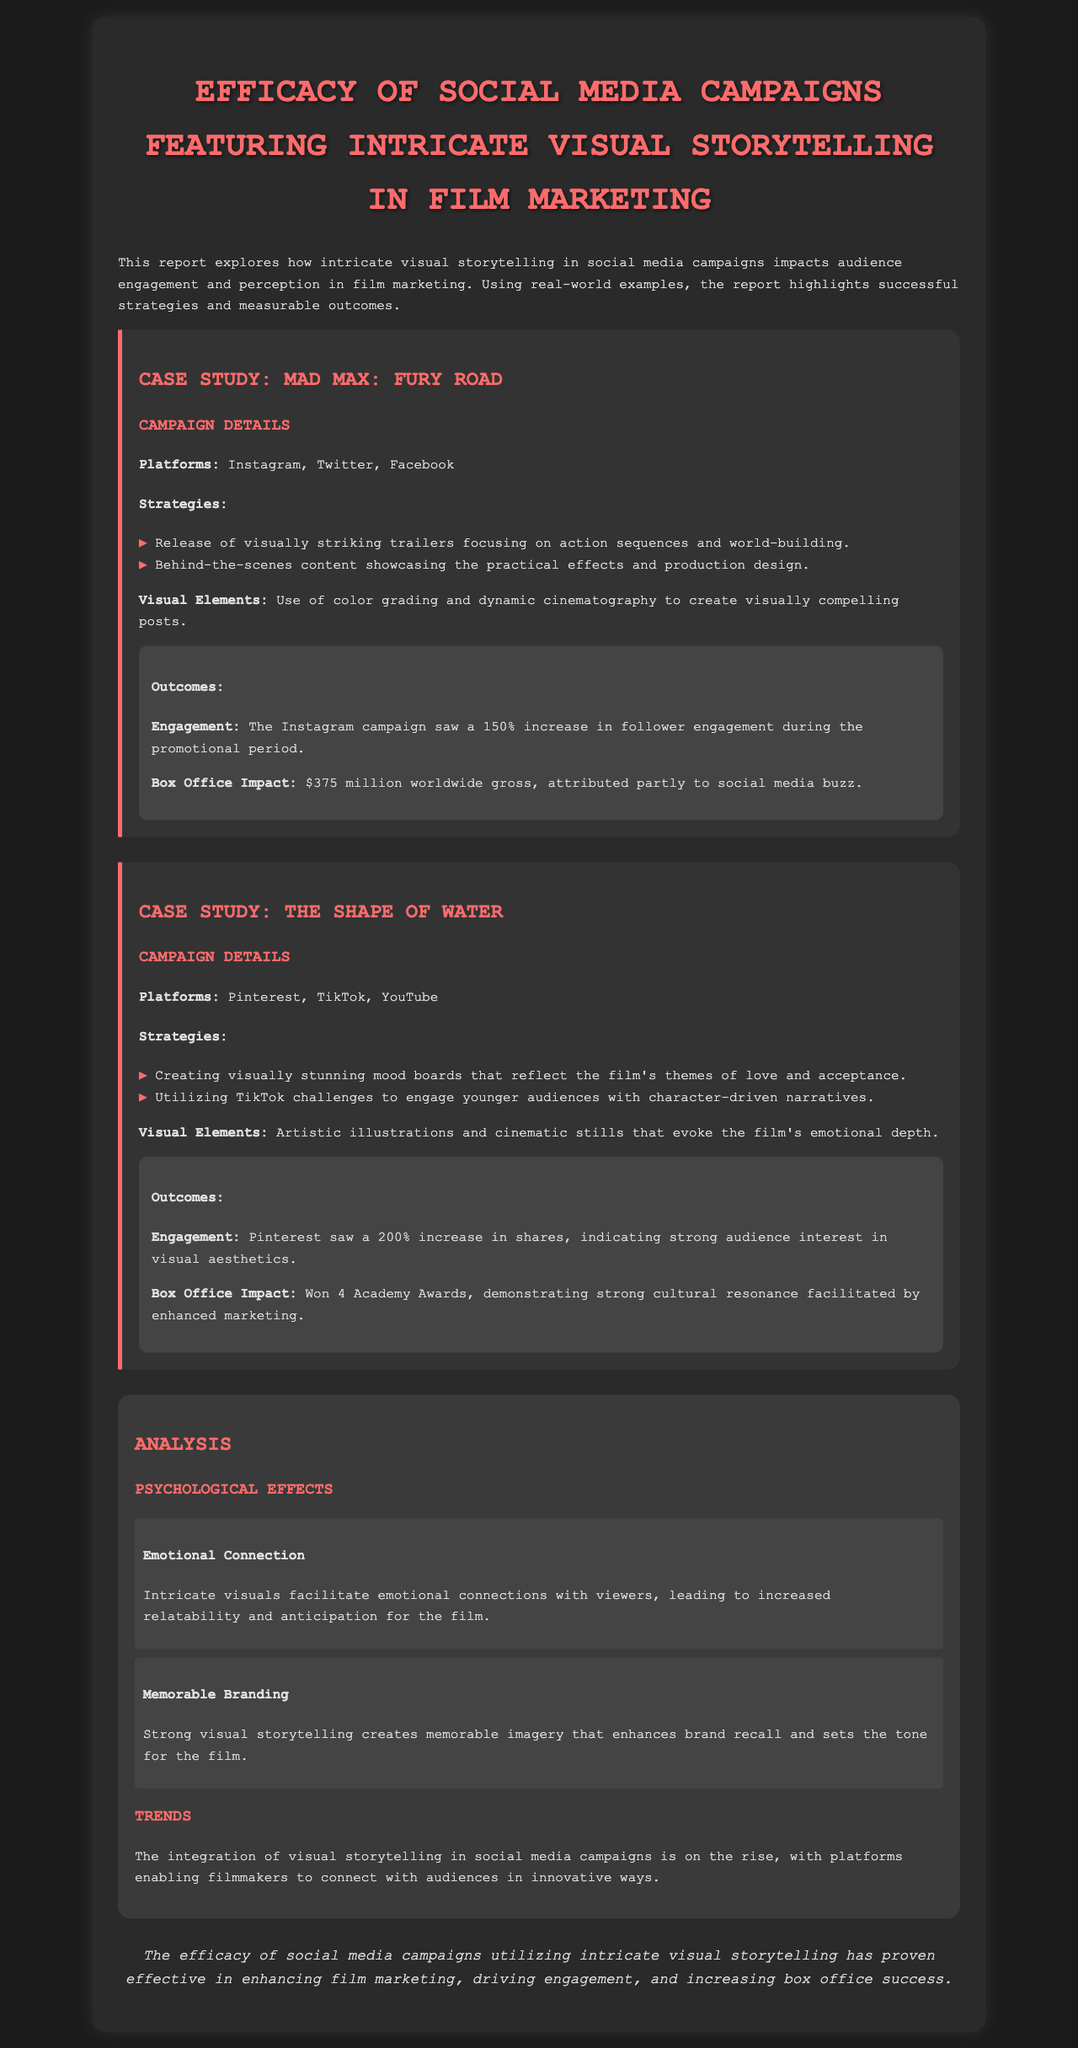what was the engagement increase percentage for Mad Max: Fury Road on Instagram? The engagement increase percentage for the Mad Max: Fury Road Instagram campaign is stated as a 150% increase during the promotional period.
Answer: 150% which platforms were used for The Shape of Water's campaign? The report lists the platforms used for The Shape of Water's campaign as Pinterest, TikTok, and YouTube.
Answer: Pinterest, TikTok, YouTube how many Academy Awards did The Shape of Water win? The document specifies that The Shape of Water won 4 Academy Awards, highlighting its strong cultural impact.
Answer: 4 what is one psychological effect of intricate visual storytelling mentioned in the report? The report mentions that intricate visuals facilitate emotional connections with viewers, indicating a psychological effect of visual storytelling.
Answer: Emotional Connection what does strong visual storytelling enhance according to the analysis? The analysis states that strong visual storytelling enhances brand recall and sets the tone for the film, highlighting its impact on marketing.
Answer: Brand recall what was the worldwide gross for Mad Max: Fury Road? The worldwide gross for Mad Max: Fury Road is given as $375 million, showcasing its financial success attributed partly to social media marketing.
Answer: $375 million what trend is noted regarding visual storytelling in social media campaigns? The report notes that the integration of visual storytelling in social media campaigns is on the rise, reflecting a trend in film marketing.
Answer: On the rise what color was used in the document's headings? The headings in the document are styled with the color #ff6b6b, which is bright and visually striking.
Answer: #ff6b6b 